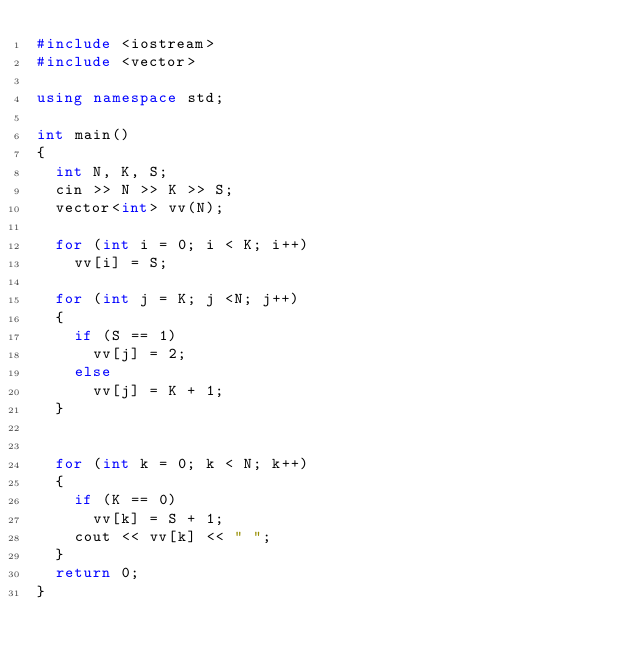<code> <loc_0><loc_0><loc_500><loc_500><_C++_>#include <iostream>
#include <vector>

using namespace std;

int main()
{
	int N, K, S;
	cin >> N >> K >> S;
	vector<int> vv(N);

	for (int i = 0; i < K; i++)
		vv[i] = S;

	for (int j = K; j <N; j++)
	{
		if (S == 1)
			vv[j] = 2;
		else
			vv[j] = K + 1;
	}
	

	for (int k = 0; k < N; k++)
	{
		if (K == 0)
			vv[k] = S + 1;
		cout << vv[k] << " ";
	}
	return 0;
}</code> 